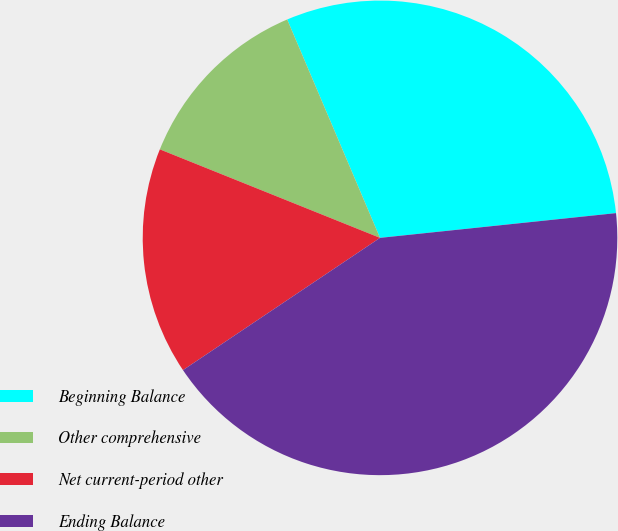Convert chart to OTSL. <chart><loc_0><loc_0><loc_500><loc_500><pie_chart><fcel>Beginning Balance<fcel>Other comprehensive<fcel>Net current-period other<fcel>Ending Balance<nl><fcel>29.73%<fcel>12.52%<fcel>15.49%<fcel>42.25%<nl></chart> 